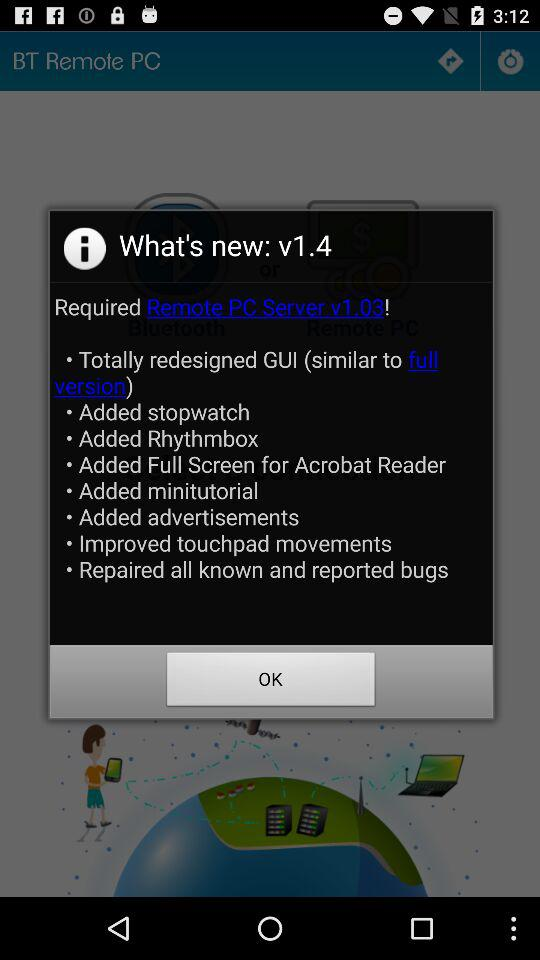How many features have been added?
Answer the question using a single word or phrase. 8 